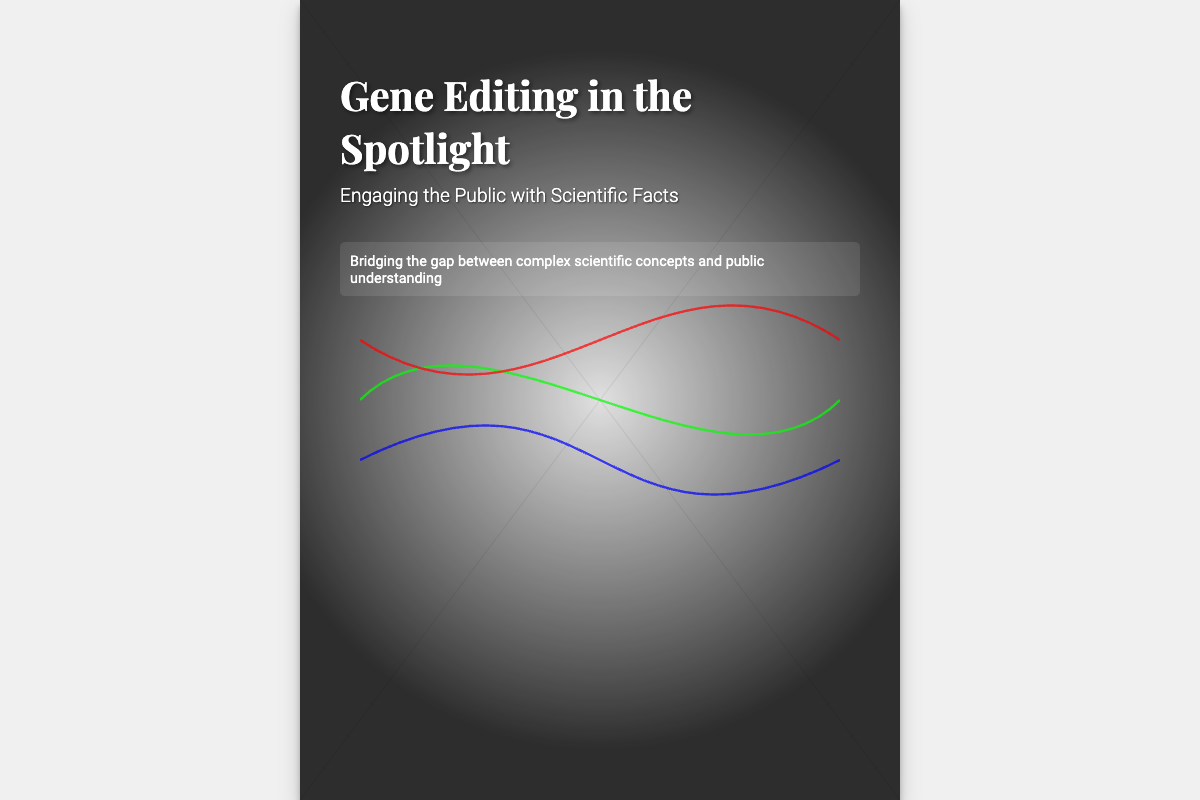What is the title of the book? The title is prominently displayed at the top of the cover as "Gene Editing in the Spotlight."
Answer: Gene Editing in the Spotlight Who is the author of the book? The author's name is mentioned at the bottom of the cover.
Answer: Dr. Sarah Emerson What is the subtitle of the book? The subtitle provides additional context to the title and reads "Engaging the Public with Scientific Facts."
Answer: Engaging the Public with Scientific Facts What is highlighted in the content section? The highlighted section bridges the gap between scientific concepts and public understanding.
Answer: Bridging the gap between complex scientific concepts and public understanding What is the dominant color of the book cover background? The background color of the book cover has a light gray tone.
Answer: Light gray What visual element represents a genome map? The genome map on the cover is an abstract illustration embedded in the design.
Answer: Abstract illustration What is the purpose of the spotlight effect on the cover? The spotlight effect serves to draw attention to the complex genome map and create visual impact.
Answer: Draw attention How does the title relate to public engagement? The title suggests a focus on making complex genetic research more accessible to the general public.
Answer: Making complex genetic research accessible What type of document is this? The format and style clearly indicate that it is a book cover for a scientific publication.
Answer: Book cover 